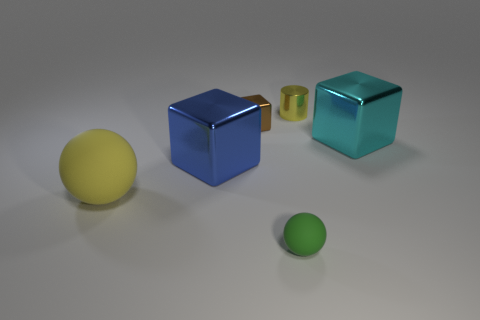There is a tiny block that is made of the same material as the cylinder; what is its color?
Your response must be concise. Brown. There is a rubber thing that is the same color as the cylinder; what is its shape?
Keep it short and to the point. Sphere. Is the size of the sphere that is right of the large blue cube the same as the metal block that is on the right side of the small green thing?
Provide a succinct answer. No. What number of cubes are big objects or tiny yellow metallic objects?
Make the answer very short. 2. Is the cube in front of the big cyan block made of the same material as the green sphere?
Offer a terse response. No. How many tiny objects are yellow metallic cylinders or green things?
Provide a short and direct response. 2. Is the small matte thing the same color as the large rubber sphere?
Your response must be concise. No. Are there more yellow rubber objects behind the yellow ball than small green rubber balls right of the cyan shiny thing?
Give a very brief answer. No. There is a tiny thing on the left side of the tiny rubber ball; is it the same color as the metallic cylinder?
Offer a terse response. No. Is there any other thing of the same color as the cylinder?
Your answer should be compact. Yes. 